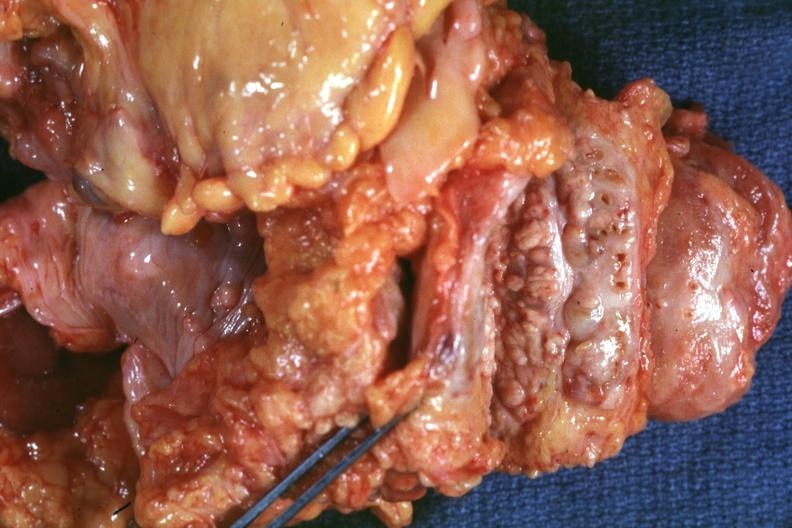how is nodular parenchyma and dense intervening tumor tissue very?
Answer the question using a single word or phrase. Good 